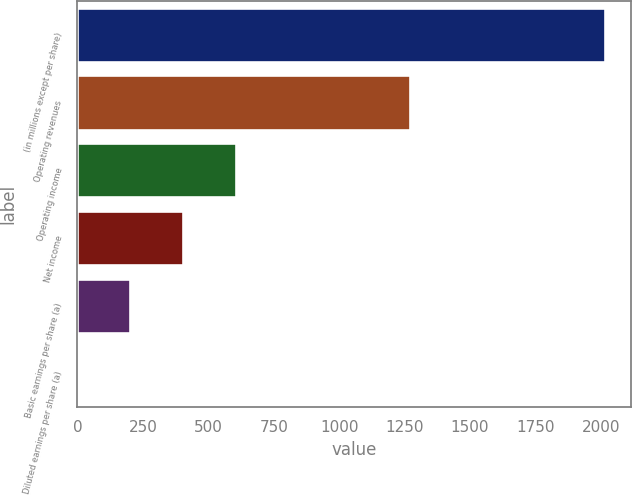Convert chart to OTSL. <chart><loc_0><loc_0><loc_500><loc_500><bar_chart><fcel>(in millions except per share)<fcel>Operating revenues<fcel>Operating income<fcel>Net income<fcel>Basic earnings per share (a)<fcel>Diluted earnings per share (a)<nl><fcel>2015<fcel>1269<fcel>605.29<fcel>403.9<fcel>202.51<fcel>1.12<nl></chart> 